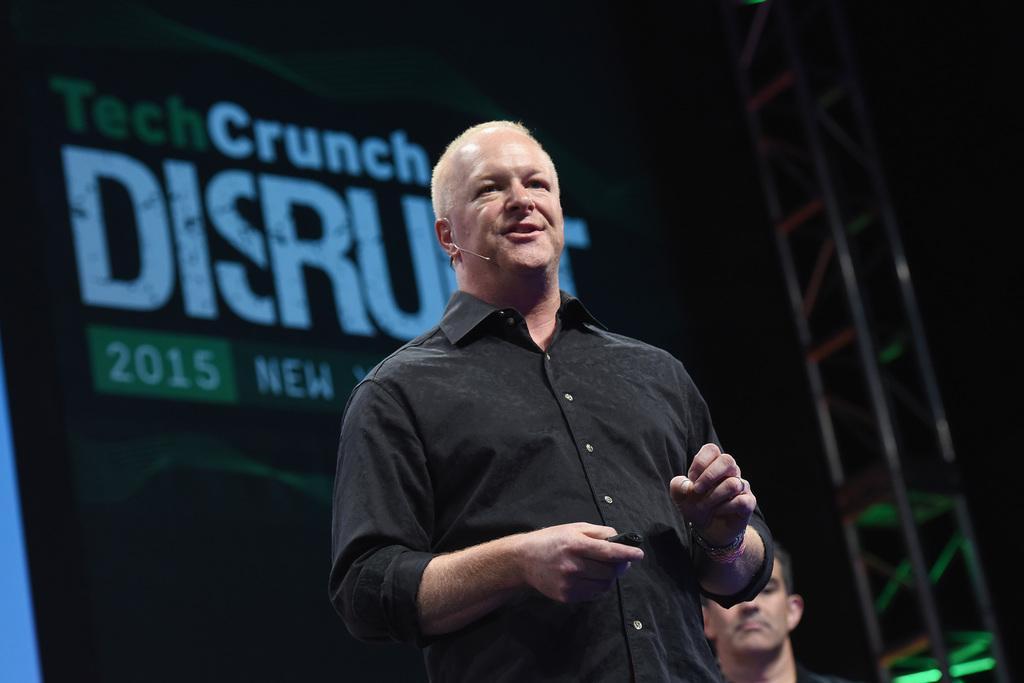How would you summarize this image in a sentence or two? Here a person is standing and speaking with the help of a microphone and back side of him we can see an advertisement hoarding 